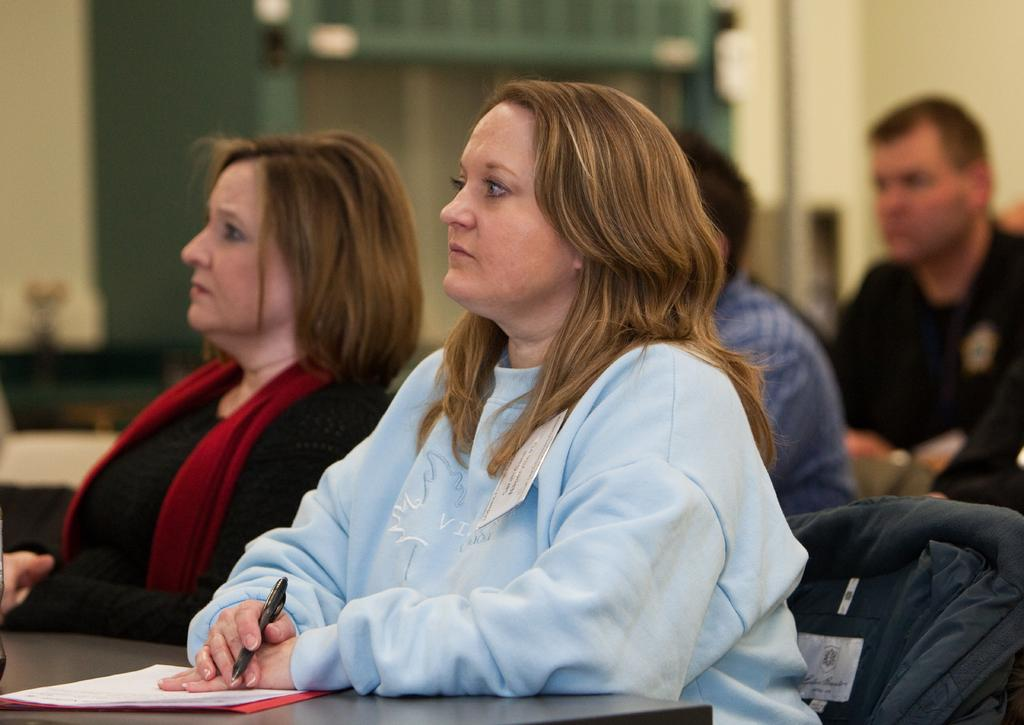What are the people in the image doing? There is a group of people sitting in the image. What objects are on the table in the image? There are papers on a table in the image. What is the woman holding in the image? A woman is holding a pen in the image. What can be seen in the background of the image? There is a wall visible in the background of the image. What type of silk is draped over the train in the image? There is no train or silk present in the image. Where is the park located in the image? There is no park present in the image. 